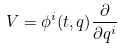<formula> <loc_0><loc_0><loc_500><loc_500>V = \phi ^ { i } ( t , q ) \frac { \partial } { \partial q ^ { i } }</formula> 